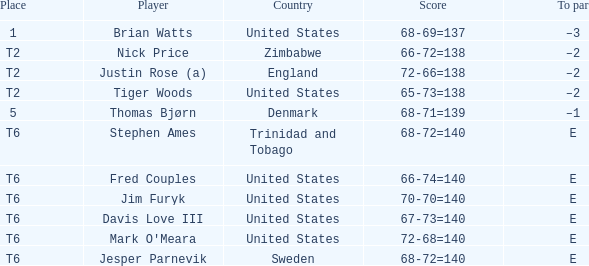What was the TO par for the player who scored 68-69=137? –3. Can you give me this table as a dict? {'header': ['Place', 'Player', 'Country', 'Score', 'To par'], 'rows': [['1', 'Brian Watts', 'United States', '68-69=137', '–3'], ['T2', 'Nick Price', 'Zimbabwe', '66-72=138', '–2'], ['T2', 'Justin Rose (a)', 'England', '72-66=138', '–2'], ['T2', 'Tiger Woods', 'United States', '65-73=138', '–2'], ['5', 'Thomas Bjørn', 'Denmark', '68-71=139', '–1'], ['T6', 'Stephen Ames', 'Trinidad and Tobago', '68-72=140', 'E'], ['T6', 'Fred Couples', 'United States', '66-74=140', 'E'], ['T6', 'Jim Furyk', 'United States', '70-70=140', 'E'], ['T6', 'Davis Love III', 'United States', '67-73=140', 'E'], ['T6', "Mark O'Meara", 'United States', '72-68=140', 'E'], ['T6', 'Jesper Parnevik', 'Sweden', '68-72=140', 'E']]} 